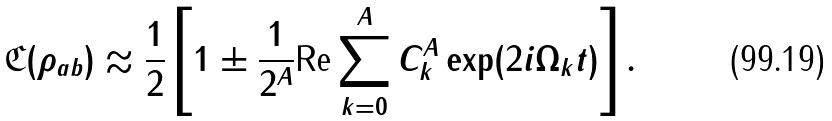<formula> <loc_0><loc_0><loc_500><loc_500>\mathfrak { C } ( \rho _ { a b } ) \approx \frac { 1 } { 2 } \left [ 1 \pm \frac { 1 } { 2 ^ { A } } \text {Re} \sum _ { k = 0 } ^ { A } C _ { k } ^ { A } \exp ( 2 i \Omega _ { k } t ) \right ] .</formula> 